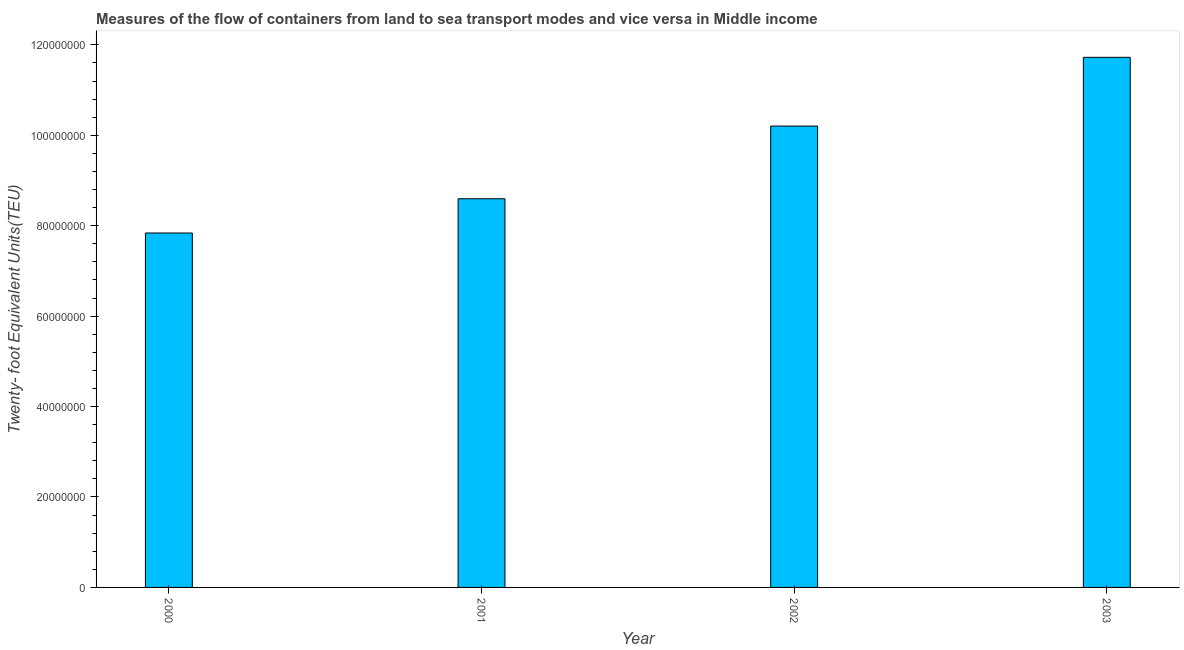Does the graph contain any zero values?
Your answer should be very brief. No. What is the title of the graph?
Your answer should be very brief. Measures of the flow of containers from land to sea transport modes and vice versa in Middle income. What is the label or title of the X-axis?
Provide a short and direct response. Year. What is the label or title of the Y-axis?
Your answer should be compact. Twenty- foot Equivalent Units(TEU). What is the container port traffic in 2000?
Make the answer very short. 7.84e+07. Across all years, what is the maximum container port traffic?
Provide a short and direct response. 1.17e+08. Across all years, what is the minimum container port traffic?
Offer a very short reply. 7.84e+07. In which year was the container port traffic maximum?
Provide a short and direct response. 2003. What is the sum of the container port traffic?
Your answer should be compact. 3.84e+08. What is the difference between the container port traffic in 2001 and 2002?
Ensure brevity in your answer.  -1.61e+07. What is the average container port traffic per year?
Provide a succinct answer. 9.59e+07. What is the median container port traffic?
Offer a very short reply. 9.40e+07. Do a majority of the years between 2002 and 2000 (inclusive) have container port traffic greater than 28000000 TEU?
Keep it short and to the point. Yes. What is the ratio of the container port traffic in 2000 to that in 2003?
Ensure brevity in your answer.  0.67. Is the container port traffic in 2002 less than that in 2003?
Your answer should be compact. Yes. Is the difference between the container port traffic in 2000 and 2001 greater than the difference between any two years?
Provide a short and direct response. No. What is the difference between the highest and the second highest container port traffic?
Give a very brief answer. 1.52e+07. Is the sum of the container port traffic in 2001 and 2002 greater than the maximum container port traffic across all years?
Ensure brevity in your answer.  Yes. What is the difference between the highest and the lowest container port traffic?
Keep it short and to the point. 3.89e+07. In how many years, is the container port traffic greater than the average container port traffic taken over all years?
Ensure brevity in your answer.  2. How many bars are there?
Your answer should be very brief. 4. What is the Twenty- foot Equivalent Units(TEU) in 2000?
Your response must be concise. 7.84e+07. What is the Twenty- foot Equivalent Units(TEU) in 2001?
Provide a succinct answer. 8.60e+07. What is the Twenty- foot Equivalent Units(TEU) of 2002?
Make the answer very short. 1.02e+08. What is the Twenty- foot Equivalent Units(TEU) in 2003?
Your answer should be compact. 1.17e+08. What is the difference between the Twenty- foot Equivalent Units(TEU) in 2000 and 2001?
Provide a succinct answer. -7.58e+06. What is the difference between the Twenty- foot Equivalent Units(TEU) in 2000 and 2002?
Give a very brief answer. -2.37e+07. What is the difference between the Twenty- foot Equivalent Units(TEU) in 2000 and 2003?
Your response must be concise. -3.89e+07. What is the difference between the Twenty- foot Equivalent Units(TEU) in 2001 and 2002?
Give a very brief answer. -1.61e+07. What is the difference between the Twenty- foot Equivalent Units(TEU) in 2001 and 2003?
Your answer should be compact. -3.13e+07. What is the difference between the Twenty- foot Equivalent Units(TEU) in 2002 and 2003?
Keep it short and to the point. -1.52e+07. What is the ratio of the Twenty- foot Equivalent Units(TEU) in 2000 to that in 2001?
Give a very brief answer. 0.91. What is the ratio of the Twenty- foot Equivalent Units(TEU) in 2000 to that in 2002?
Your response must be concise. 0.77. What is the ratio of the Twenty- foot Equivalent Units(TEU) in 2000 to that in 2003?
Make the answer very short. 0.67. What is the ratio of the Twenty- foot Equivalent Units(TEU) in 2001 to that in 2002?
Provide a short and direct response. 0.84. What is the ratio of the Twenty- foot Equivalent Units(TEU) in 2001 to that in 2003?
Give a very brief answer. 0.73. What is the ratio of the Twenty- foot Equivalent Units(TEU) in 2002 to that in 2003?
Your response must be concise. 0.87. 